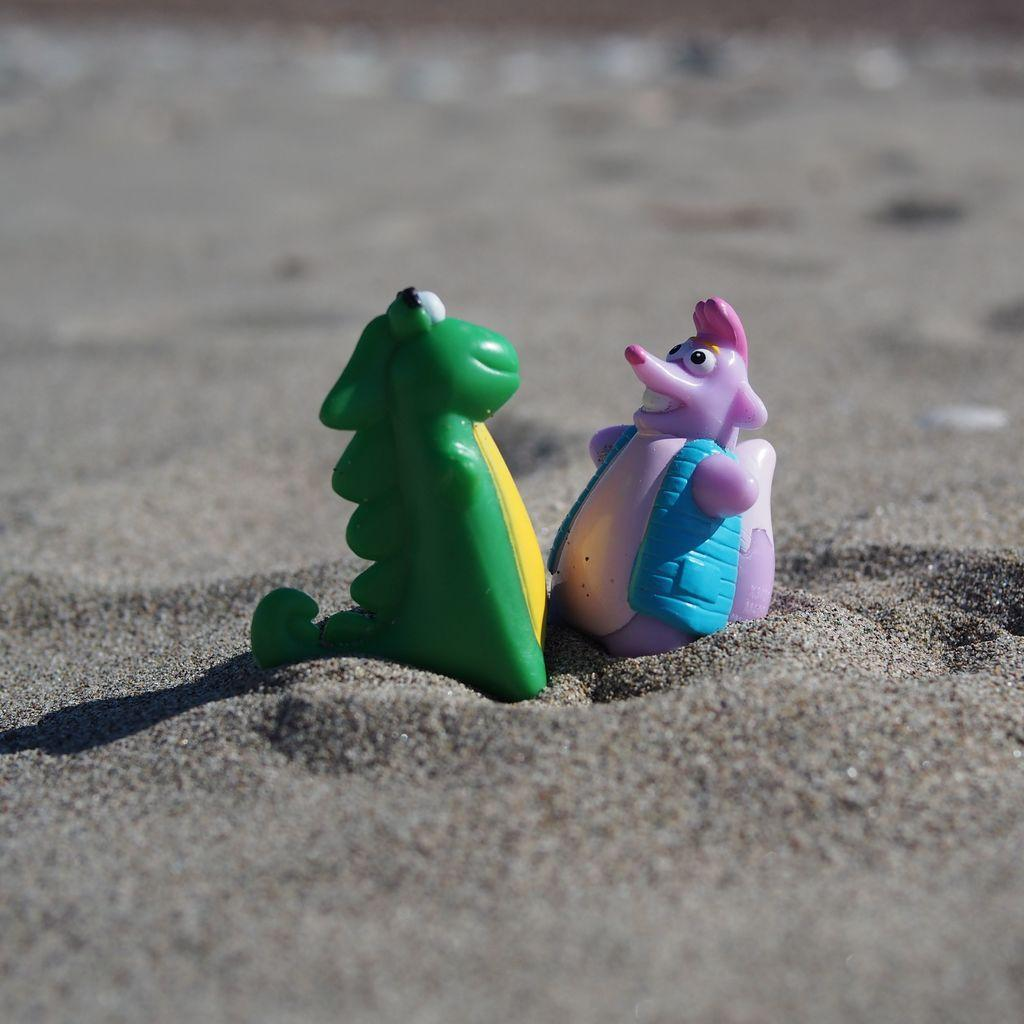Where was the image taken? The image was taken outdoors. What type of terrain is visible in the image? There is sand on the ground in the image. What can be seen in the sand in the image? There are two toys in the sand in the image. What type of discussion is taking place in the image? There is no discussion taking place in the image; it is a still image of sand and toys. Can you see a car driving through the sand in the image? There is no car visible in the image; it only shows sand and two toys. 